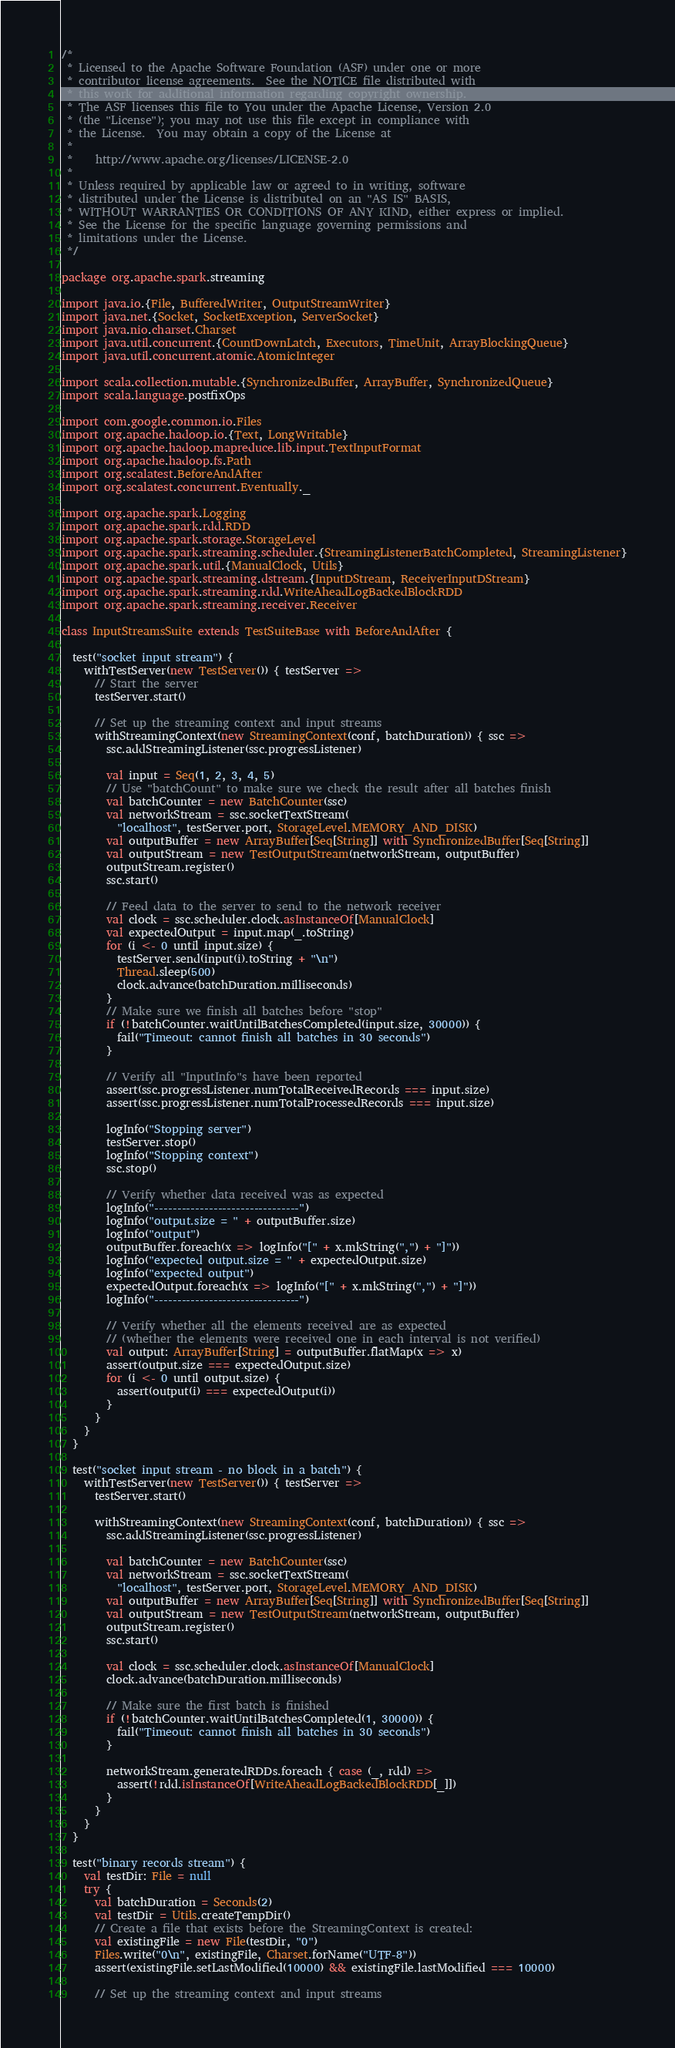Convert code to text. <code><loc_0><loc_0><loc_500><loc_500><_Scala_>/*
 * Licensed to the Apache Software Foundation (ASF) under one or more
 * contributor license agreements.  See the NOTICE file distributed with
 * this work for additional information regarding copyright ownership.
 * The ASF licenses this file to You under the Apache License, Version 2.0
 * (the "License"); you may not use this file except in compliance with
 * the License.  You may obtain a copy of the License at
 *
 *    http://www.apache.org/licenses/LICENSE-2.0
 *
 * Unless required by applicable law or agreed to in writing, software
 * distributed under the License is distributed on an "AS IS" BASIS,
 * WITHOUT WARRANTIES OR CONDITIONS OF ANY KIND, either express or implied.
 * See the License for the specific language governing permissions and
 * limitations under the License.
 */

package org.apache.spark.streaming

import java.io.{File, BufferedWriter, OutputStreamWriter}
import java.net.{Socket, SocketException, ServerSocket}
import java.nio.charset.Charset
import java.util.concurrent.{CountDownLatch, Executors, TimeUnit, ArrayBlockingQueue}
import java.util.concurrent.atomic.AtomicInteger

import scala.collection.mutable.{SynchronizedBuffer, ArrayBuffer, SynchronizedQueue}
import scala.language.postfixOps

import com.google.common.io.Files
import org.apache.hadoop.io.{Text, LongWritable}
import org.apache.hadoop.mapreduce.lib.input.TextInputFormat
import org.apache.hadoop.fs.Path
import org.scalatest.BeforeAndAfter
import org.scalatest.concurrent.Eventually._

import org.apache.spark.Logging
import org.apache.spark.rdd.RDD
import org.apache.spark.storage.StorageLevel
import org.apache.spark.streaming.scheduler.{StreamingListenerBatchCompleted, StreamingListener}
import org.apache.spark.util.{ManualClock, Utils}
import org.apache.spark.streaming.dstream.{InputDStream, ReceiverInputDStream}
import org.apache.spark.streaming.rdd.WriteAheadLogBackedBlockRDD
import org.apache.spark.streaming.receiver.Receiver

class InputStreamsSuite extends TestSuiteBase with BeforeAndAfter {

  test("socket input stream") {
    withTestServer(new TestServer()) { testServer =>
      // Start the server
      testServer.start()

      // Set up the streaming context and input streams
      withStreamingContext(new StreamingContext(conf, batchDuration)) { ssc =>
        ssc.addStreamingListener(ssc.progressListener)

        val input = Seq(1, 2, 3, 4, 5)
        // Use "batchCount" to make sure we check the result after all batches finish
        val batchCounter = new BatchCounter(ssc)
        val networkStream = ssc.socketTextStream(
          "localhost", testServer.port, StorageLevel.MEMORY_AND_DISK)
        val outputBuffer = new ArrayBuffer[Seq[String]] with SynchronizedBuffer[Seq[String]]
        val outputStream = new TestOutputStream(networkStream, outputBuffer)
        outputStream.register()
        ssc.start()

        // Feed data to the server to send to the network receiver
        val clock = ssc.scheduler.clock.asInstanceOf[ManualClock]
        val expectedOutput = input.map(_.toString)
        for (i <- 0 until input.size) {
          testServer.send(input(i).toString + "\n")
          Thread.sleep(500)
          clock.advance(batchDuration.milliseconds)
        }
        // Make sure we finish all batches before "stop"
        if (!batchCounter.waitUntilBatchesCompleted(input.size, 30000)) {
          fail("Timeout: cannot finish all batches in 30 seconds")
        }

        // Verify all "InputInfo"s have been reported
        assert(ssc.progressListener.numTotalReceivedRecords === input.size)
        assert(ssc.progressListener.numTotalProcessedRecords === input.size)

        logInfo("Stopping server")
        testServer.stop()
        logInfo("Stopping context")
        ssc.stop()

        // Verify whether data received was as expected
        logInfo("--------------------------------")
        logInfo("output.size = " + outputBuffer.size)
        logInfo("output")
        outputBuffer.foreach(x => logInfo("[" + x.mkString(",") + "]"))
        logInfo("expected output.size = " + expectedOutput.size)
        logInfo("expected output")
        expectedOutput.foreach(x => logInfo("[" + x.mkString(",") + "]"))
        logInfo("--------------------------------")

        // Verify whether all the elements received are as expected
        // (whether the elements were received one in each interval is not verified)
        val output: ArrayBuffer[String] = outputBuffer.flatMap(x => x)
        assert(output.size === expectedOutput.size)
        for (i <- 0 until output.size) {
          assert(output(i) === expectedOutput(i))
        }
      }
    }
  }

  test("socket input stream - no block in a batch") {
    withTestServer(new TestServer()) { testServer =>
      testServer.start()

      withStreamingContext(new StreamingContext(conf, batchDuration)) { ssc =>
        ssc.addStreamingListener(ssc.progressListener)

        val batchCounter = new BatchCounter(ssc)
        val networkStream = ssc.socketTextStream(
          "localhost", testServer.port, StorageLevel.MEMORY_AND_DISK)
        val outputBuffer = new ArrayBuffer[Seq[String]] with SynchronizedBuffer[Seq[String]]
        val outputStream = new TestOutputStream(networkStream, outputBuffer)
        outputStream.register()
        ssc.start()

        val clock = ssc.scheduler.clock.asInstanceOf[ManualClock]
        clock.advance(batchDuration.milliseconds)

        // Make sure the first batch is finished
        if (!batchCounter.waitUntilBatchesCompleted(1, 30000)) {
          fail("Timeout: cannot finish all batches in 30 seconds")
        }

        networkStream.generatedRDDs.foreach { case (_, rdd) =>
          assert(!rdd.isInstanceOf[WriteAheadLogBackedBlockRDD[_]])
        }
      }
    }
  }

  test("binary records stream") {
    val testDir: File = null
    try {
      val batchDuration = Seconds(2)
      val testDir = Utils.createTempDir()
      // Create a file that exists before the StreamingContext is created:
      val existingFile = new File(testDir, "0")
      Files.write("0\n", existingFile, Charset.forName("UTF-8"))
      assert(existingFile.setLastModified(10000) && existingFile.lastModified === 10000)

      // Set up the streaming context and input streams</code> 